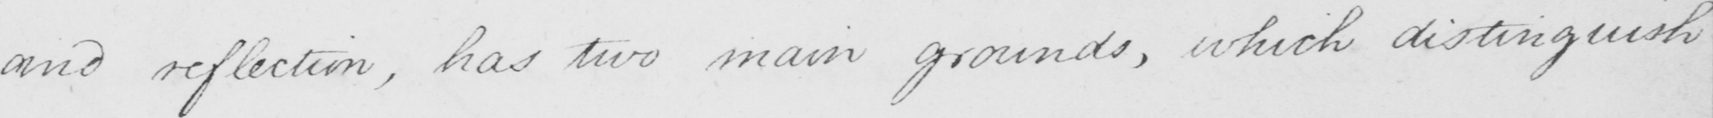Please transcribe the handwritten text in this image. and reflection , has two main grounds , which distinguish 